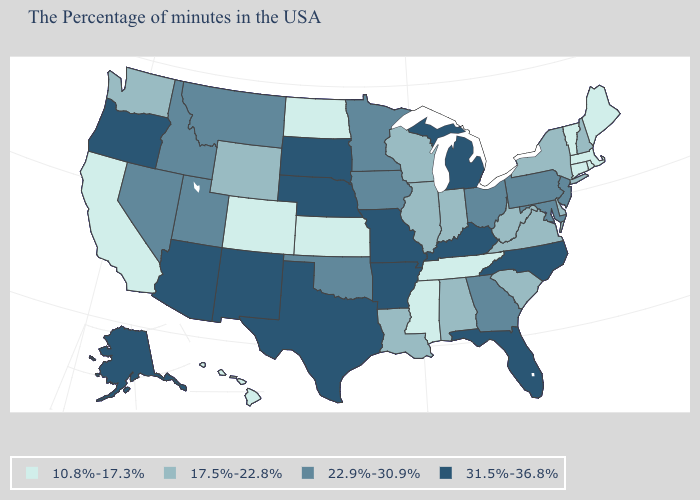Does the map have missing data?
Be succinct. No. What is the value of Florida?
Write a very short answer. 31.5%-36.8%. Name the states that have a value in the range 17.5%-22.8%?
Give a very brief answer. New Hampshire, New York, Delaware, Virginia, South Carolina, West Virginia, Indiana, Alabama, Wisconsin, Illinois, Louisiana, Wyoming, Washington. What is the highest value in the USA?
Write a very short answer. 31.5%-36.8%. What is the value of Washington?
Keep it brief. 17.5%-22.8%. What is the lowest value in the USA?
Write a very short answer. 10.8%-17.3%. What is the value of South Dakota?
Be succinct. 31.5%-36.8%. Does the first symbol in the legend represent the smallest category?
Give a very brief answer. Yes. Does Mississippi have the lowest value in the USA?
Short answer required. Yes. Does West Virginia have the highest value in the USA?
Answer briefly. No. Does Tennessee have a higher value than Utah?
Quick response, please. No. Does Virginia have the highest value in the South?
Quick response, please. No. Name the states that have a value in the range 17.5%-22.8%?
Be succinct. New Hampshire, New York, Delaware, Virginia, South Carolina, West Virginia, Indiana, Alabama, Wisconsin, Illinois, Louisiana, Wyoming, Washington. Which states have the lowest value in the MidWest?
Write a very short answer. Kansas, North Dakota. Does Colorado have the highest value in the USA?
Write a very short answer. No. 